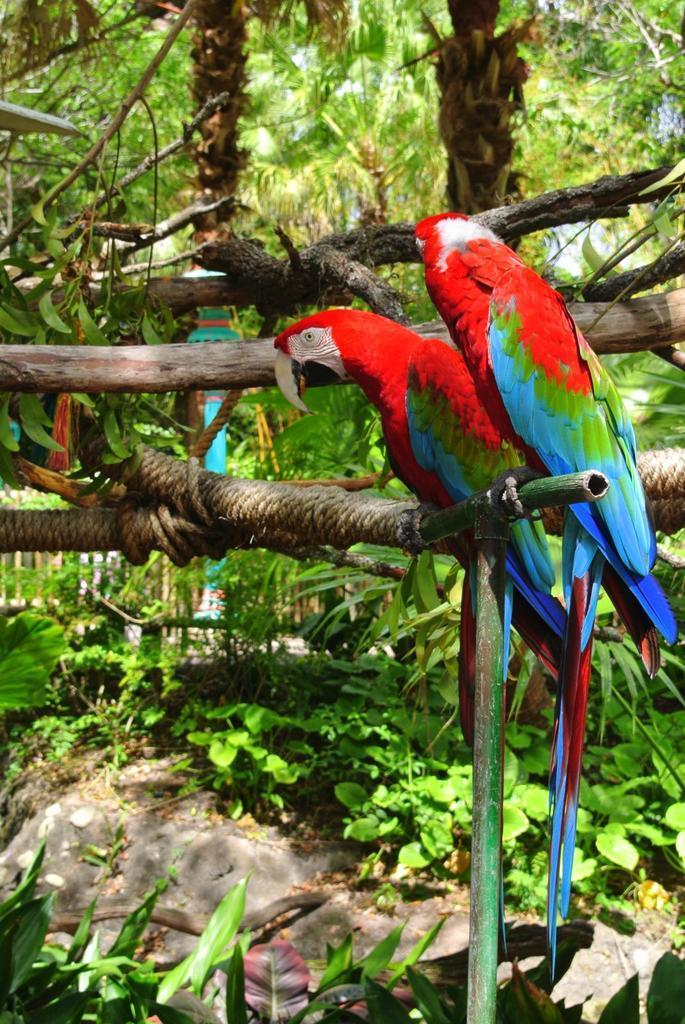Describe this image in one or two sentences. In this image we can see two parrots standing on the branch of a tree. In the background we can see wooden fence, rocks and plants. 